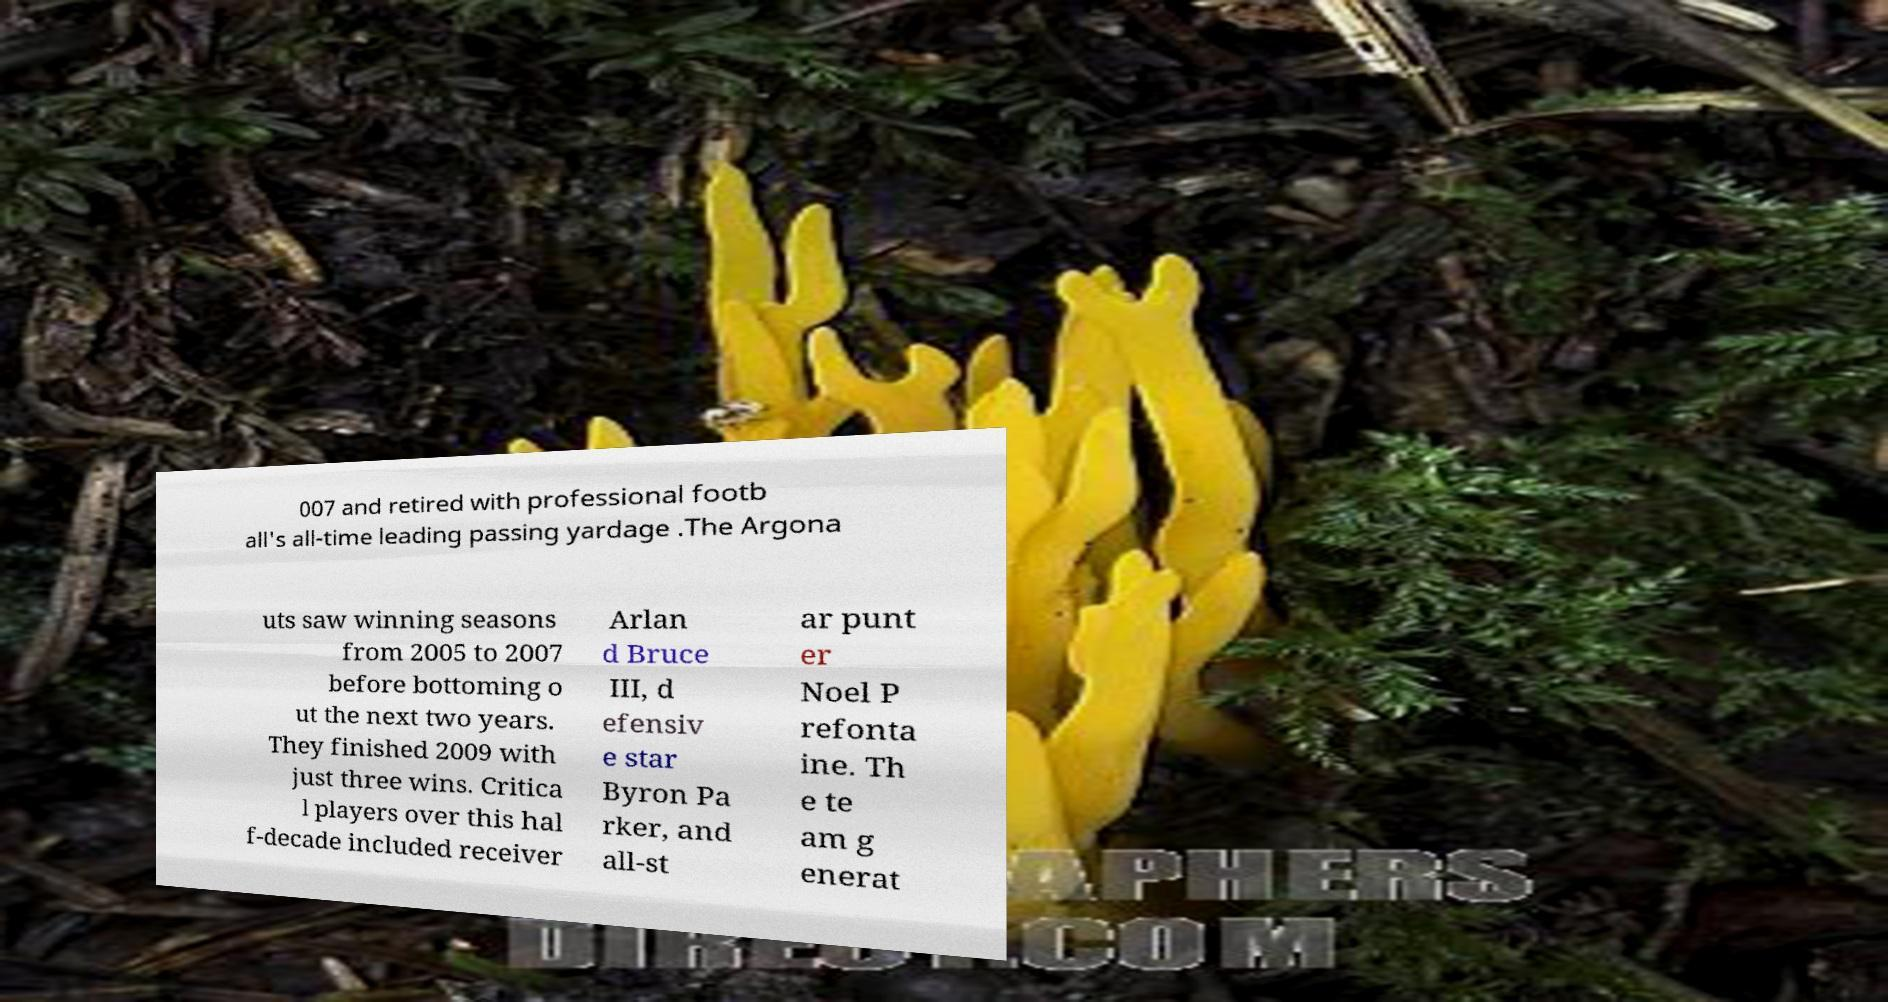Please identify and transcribe the text found in this image. 007 and retired with professional footb all's all-time leading passing yardage .The Argona uts saw winning seasons from 2005 to 2007 before bottoming o ut the next two years. They finished 2009 with just three wins. Critica l players over this hal f-decade included receiver Arlan d Bruce III, d efensiv e star Byron Pa rker, and all-st ar punt er Noel P refonta ine. Th e te am g enerat 